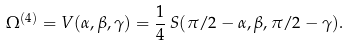Convert formula to latex. <formula><loc_0><loc_0><loc_500><loc_500>\Omega ^ { ( 4 ) } = V ( \alpha , \beta , \gamma ) = { \frac { 1 } { 4 } } \, S ( \pi / 2 - \alpha , \beta , \pi / 2 - \gamma ) .</formula> 